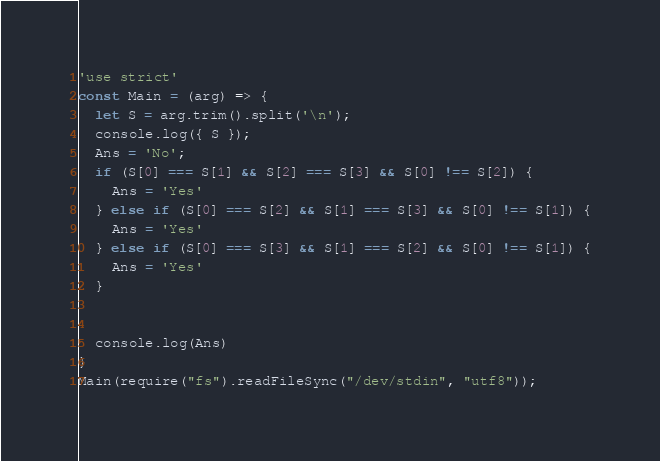Convert code to text. <code><loc_0><loc_0><loc_500><loc_500><_JavaScript_>'use strict'
const Main = (arg) => {
  let S = arg.trim().split('\n');
  console.log({ S });
  Ans = 'No';
  if (S[0] === S[1] && S[2] === S[3] && S[0] !== S[2]) {
    Ans = 'Yes'
  } else if (S[0] === S[2] && S[1] === S[3] && S[0] !== S[1]) {
    Ans = 'Yes'
  } else if (S[0] === S[3] && S[1] === S[2] && S[0] !== S[1]) {
    Ans = 'Yes'
  }
  
  
  console.log(Ans)
}
Main(require("fs").readFileSync("/dev/stdin", "utf8"));
</code> 